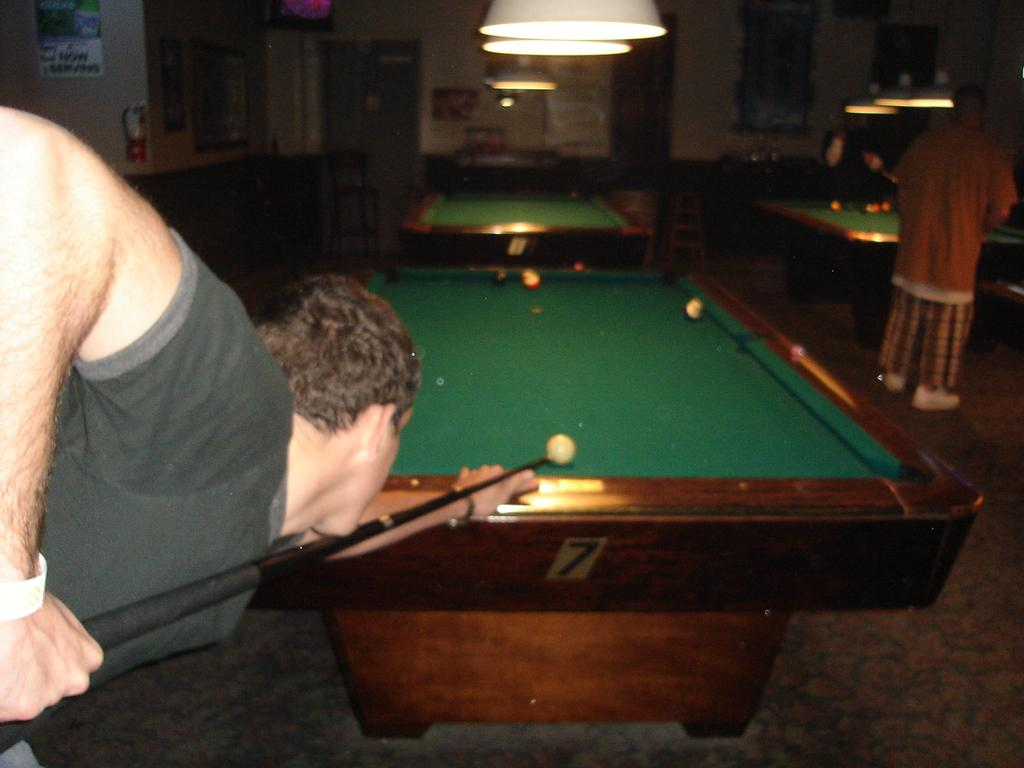What is the man in the image doing? The man is playing a snooker game. How many snooker tables can be seen in the background? There are two snooker tables in the background. What is the position of the two men in the image? Two men are standing at the right side of the image. Can you describe the lighting in the image? There is a light hanging in the image. What type of sky can be seen through the border of the image? There is no sky visible in the image, and the concept of a "border" of the image is not relevant to the content of the image. 